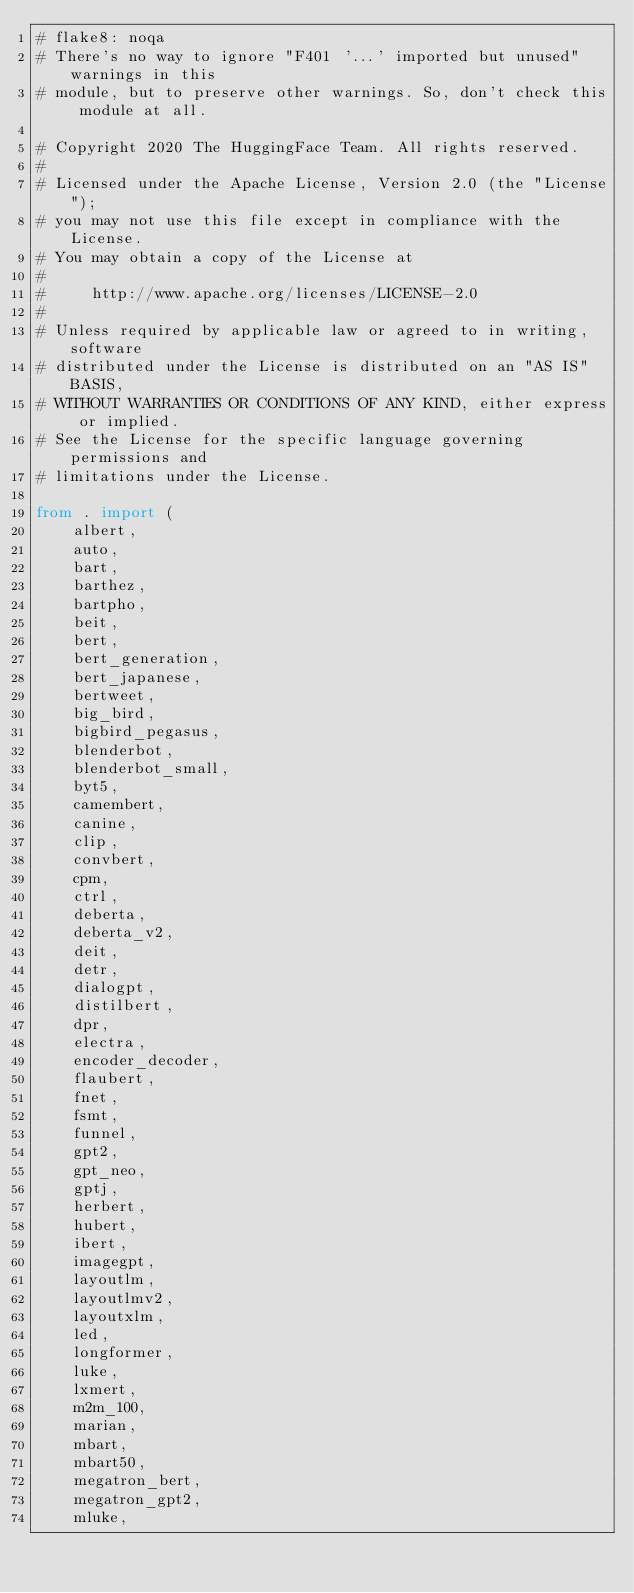Convert code to text. <code><loc_0><loc_0><loc_500><loc_500><_Python_># flake8: noqa
# There's no way to ignore "F401 '...' imported but unused" warnings in this
# module, but to preserve other warnings. So, don't check this module at all.

# Copyright 2020 The HuggingFace Team. All rights reserved.
#
# Licensed under the Apache License, Version 2.0 (the "License");
# you may not use this file except in compliance with the License.
# You may obtain a copy of the License at
#
#     http://www.apache.org/licenses/LICENSE-2.0
#
# Unless required by applicable law or agreed to in writing, software
# distributed under the License is distributed on an "AS IS" BASIS,
# WITHOUT WARRANTIES OR CONDITIONS OF ANY KIND, either express or implied.
# See the License for the specific language governing permissions and
# limitations under the License.

from . import (
    albert,
    auto,
    bart,
    barthez,
    bartpho,
    beit,
    bert,
    bert_generation,
    bert_japanese,
    bertweet,
    big_bird,
    bigbird_pegasus,
    blenderbot,
    blenderbot_small,
    byt5,
    camembert,
    canine,
    clip,
    convbert,
    cpm,
    ctrl,
    deberta,
    deberta_v2,
    deit,
    detr,
    dialogpt,
    distilbert,
    dpr,
    electra,
    encoder_decoder,
    flaubert,
    fnet,
    fsmt,
    funnel,
    gpt2,
    gpt_neo,
    gptj,
    herbert,
    hubert,
    ibert,
    imagegpt,
    layoutlm,
    layoutlmv2,
    layoutxlm,
    led,
    longformer,
    luke,
    lxmert,
    m2m_100,
    marian,
    mbart,
    mbart50,
    megatron_bert,
    megatron_gpt2,
    mluke,</code> 